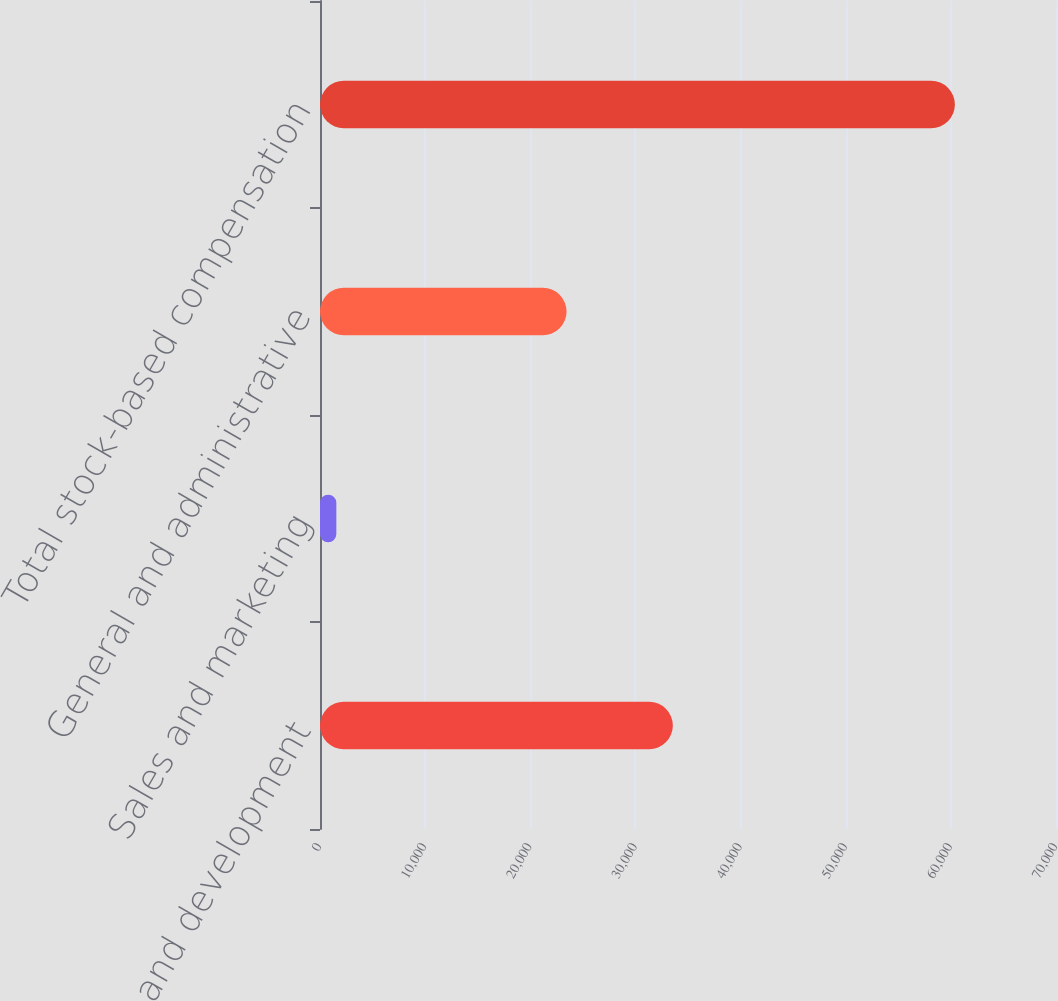<chart> <loc_0><loc_0><loc_500><loc_500><bar_chart><fcel>Research and development<fcel>Sales and marketing<fcel>General and administrative<fcel>Total stock-based compensation<nl><fcel>33559<fcel>1553<fcel>23452<fcel>60384<nl></chart> 